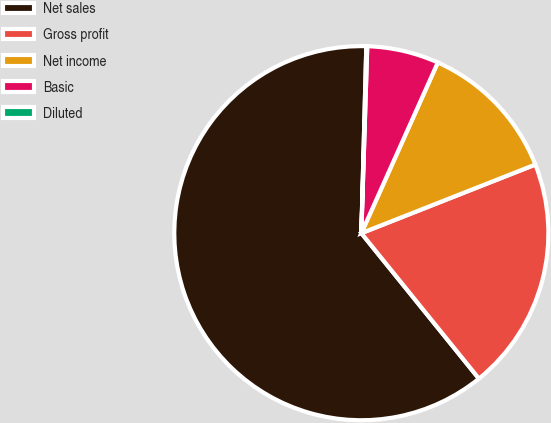Convert chart to OTSL. <chart><loc_0><loc_0><loc_500><loc_500><pie_chart><fcel>Net sales<fcel>Gross profit<fcel>Net income<fcel>Basic<fcel>Diluted<nl><fcel>61.25%<fcel>20.16%<fcel>12.32%<fcel>6.2%<fcel>0.08%<nl></chart> 